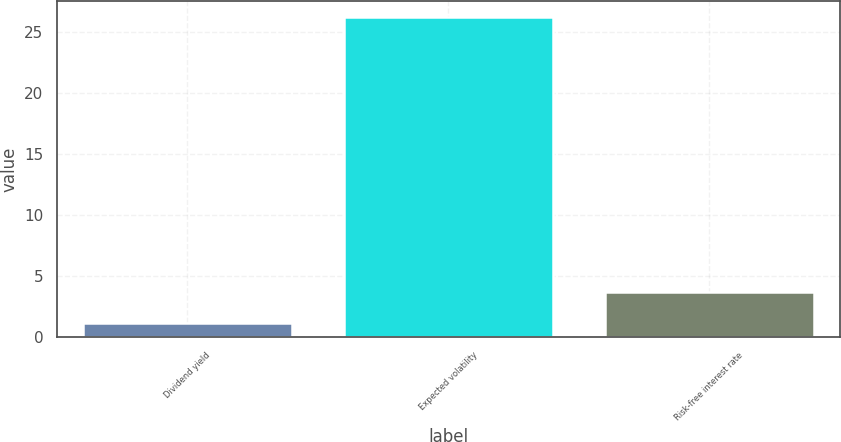<chart> <loc_0><loc_0><loc_500><loc_500><bar_chart><fcel>Dividend yield<fcel>Expected volatility<fcel>Risk-free interest rate<nl><fcel>1.2<fcel>26.27<fcel>3.71<nl></chart> 